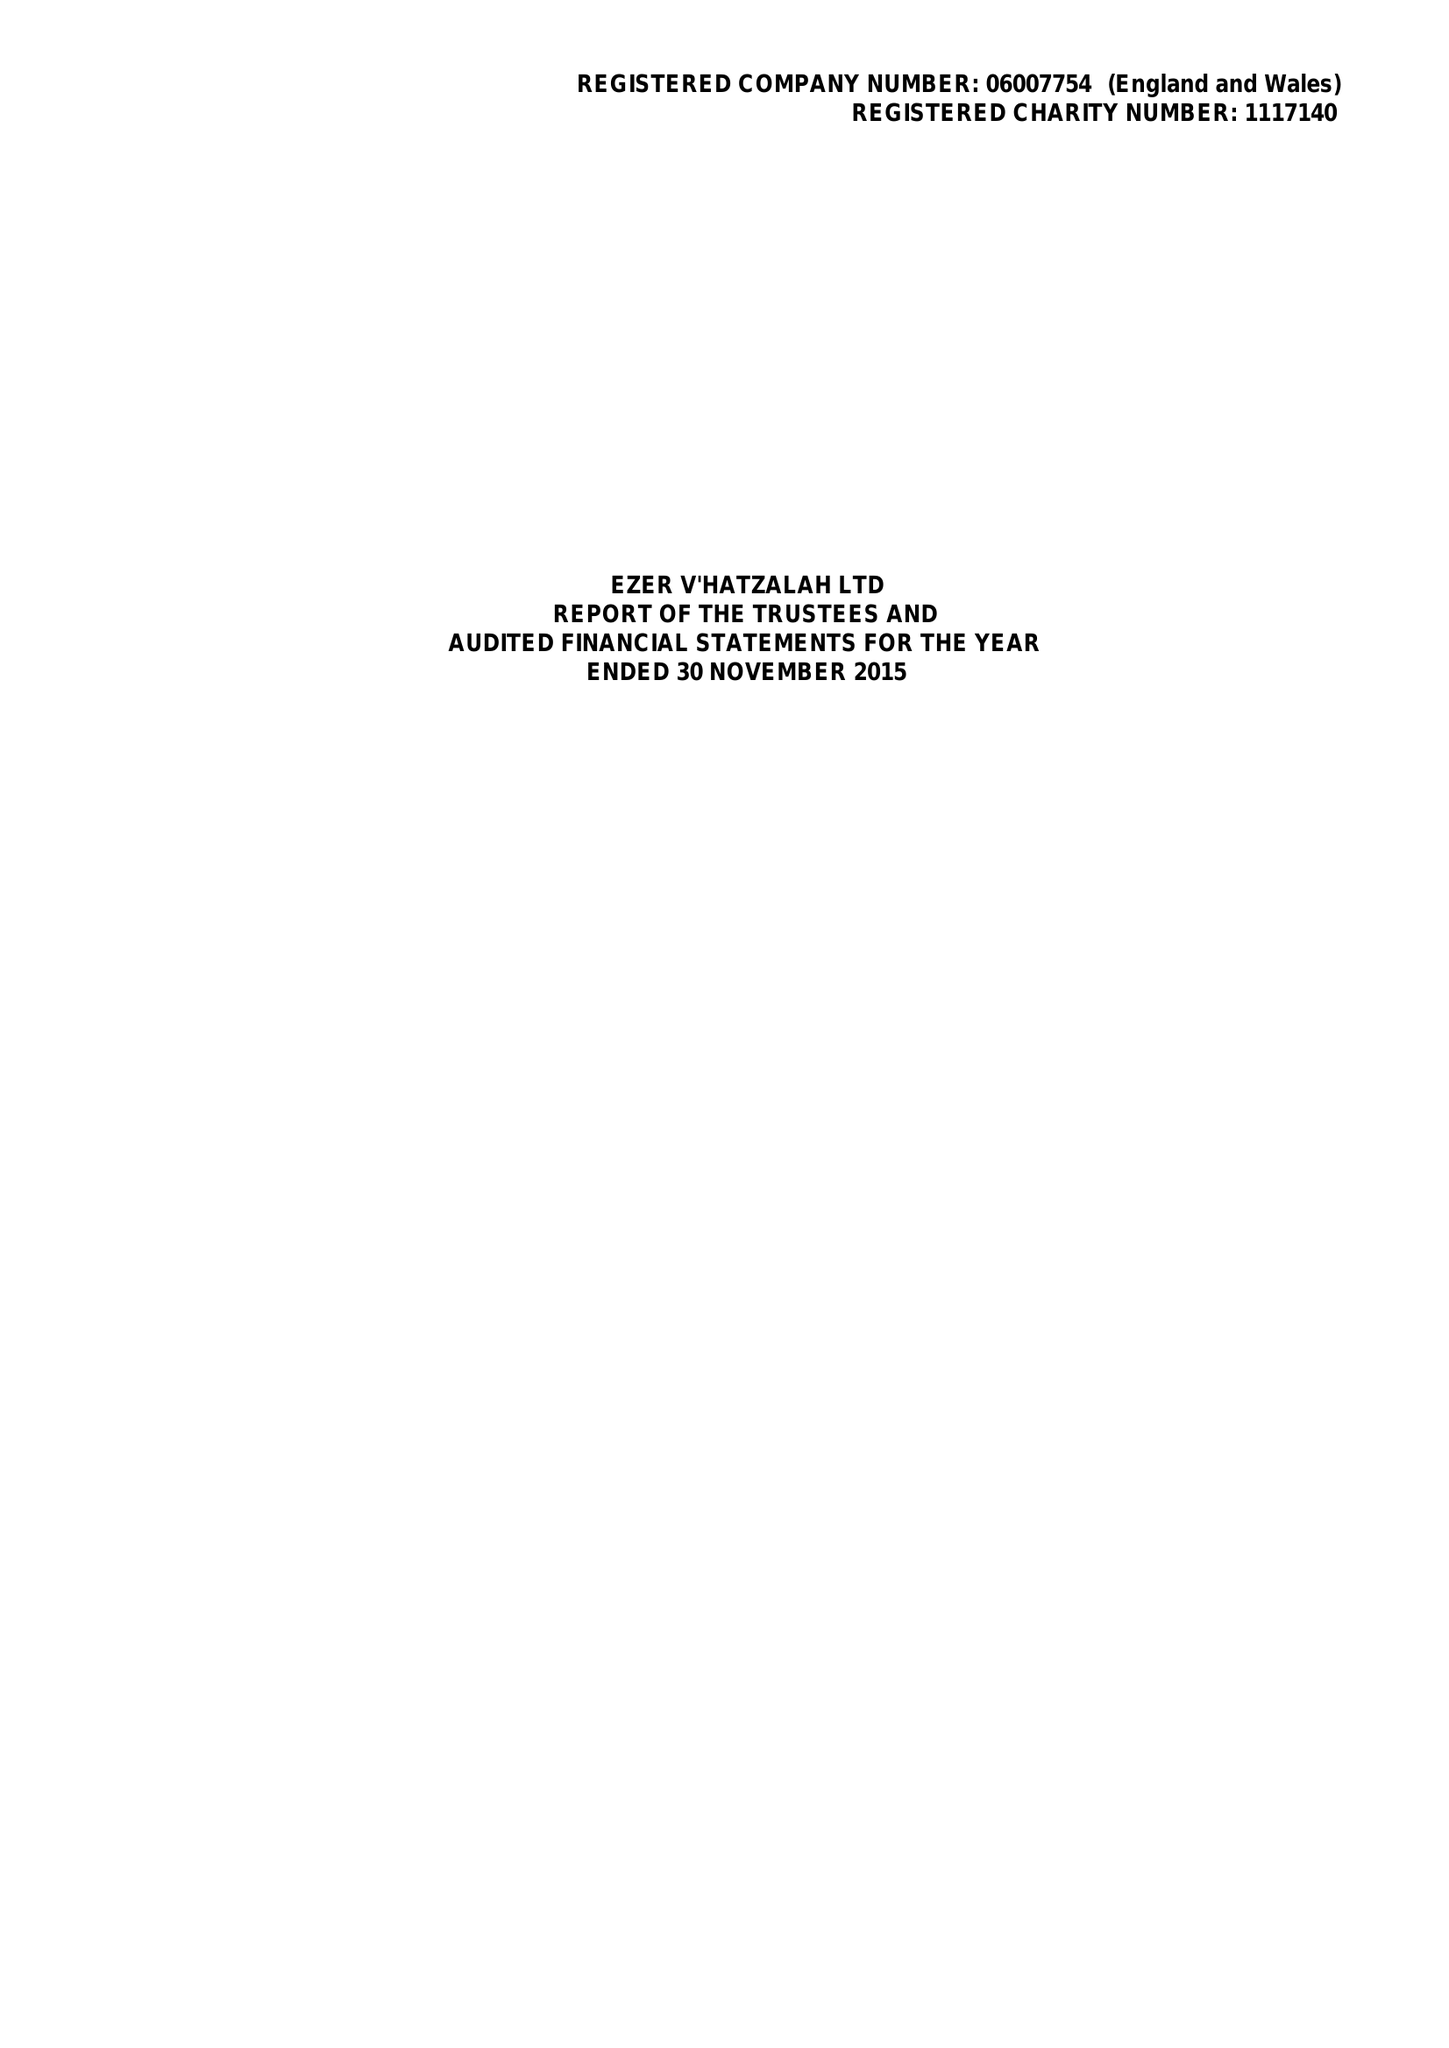What is the value for the spending_annually_in_british_pounds?
Answer the question using a single word or phrase. 9144684.00 